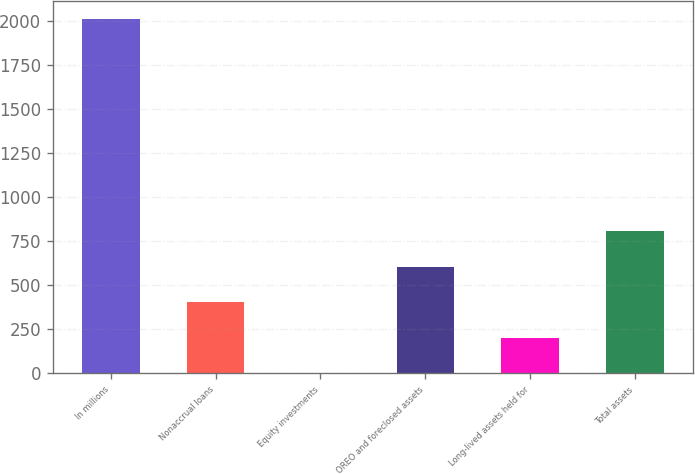Convert chart. <chart><loc_0><loc_0><loc_500><loc_500><bar_chart><fcel>In millions<fcel>Nonaccrual loans<fcel>Equity investments<fcel>OREO and foreclosed assets<fcel>Long-lived assets held for<fcel>Total assets<nl><fcel>2014<fcel>404.4<fcel>2<fcel>605.6<fcel>203.2<fcel>806.8<nl></chart> 